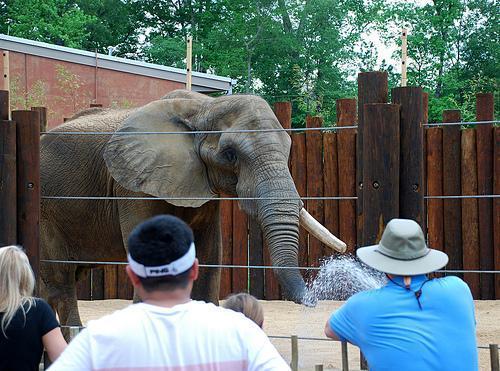How many elephants are in the picture?
Give a very brief answer. 1. How many tusks does the elephant have?
Give a very brief answer. 1. 